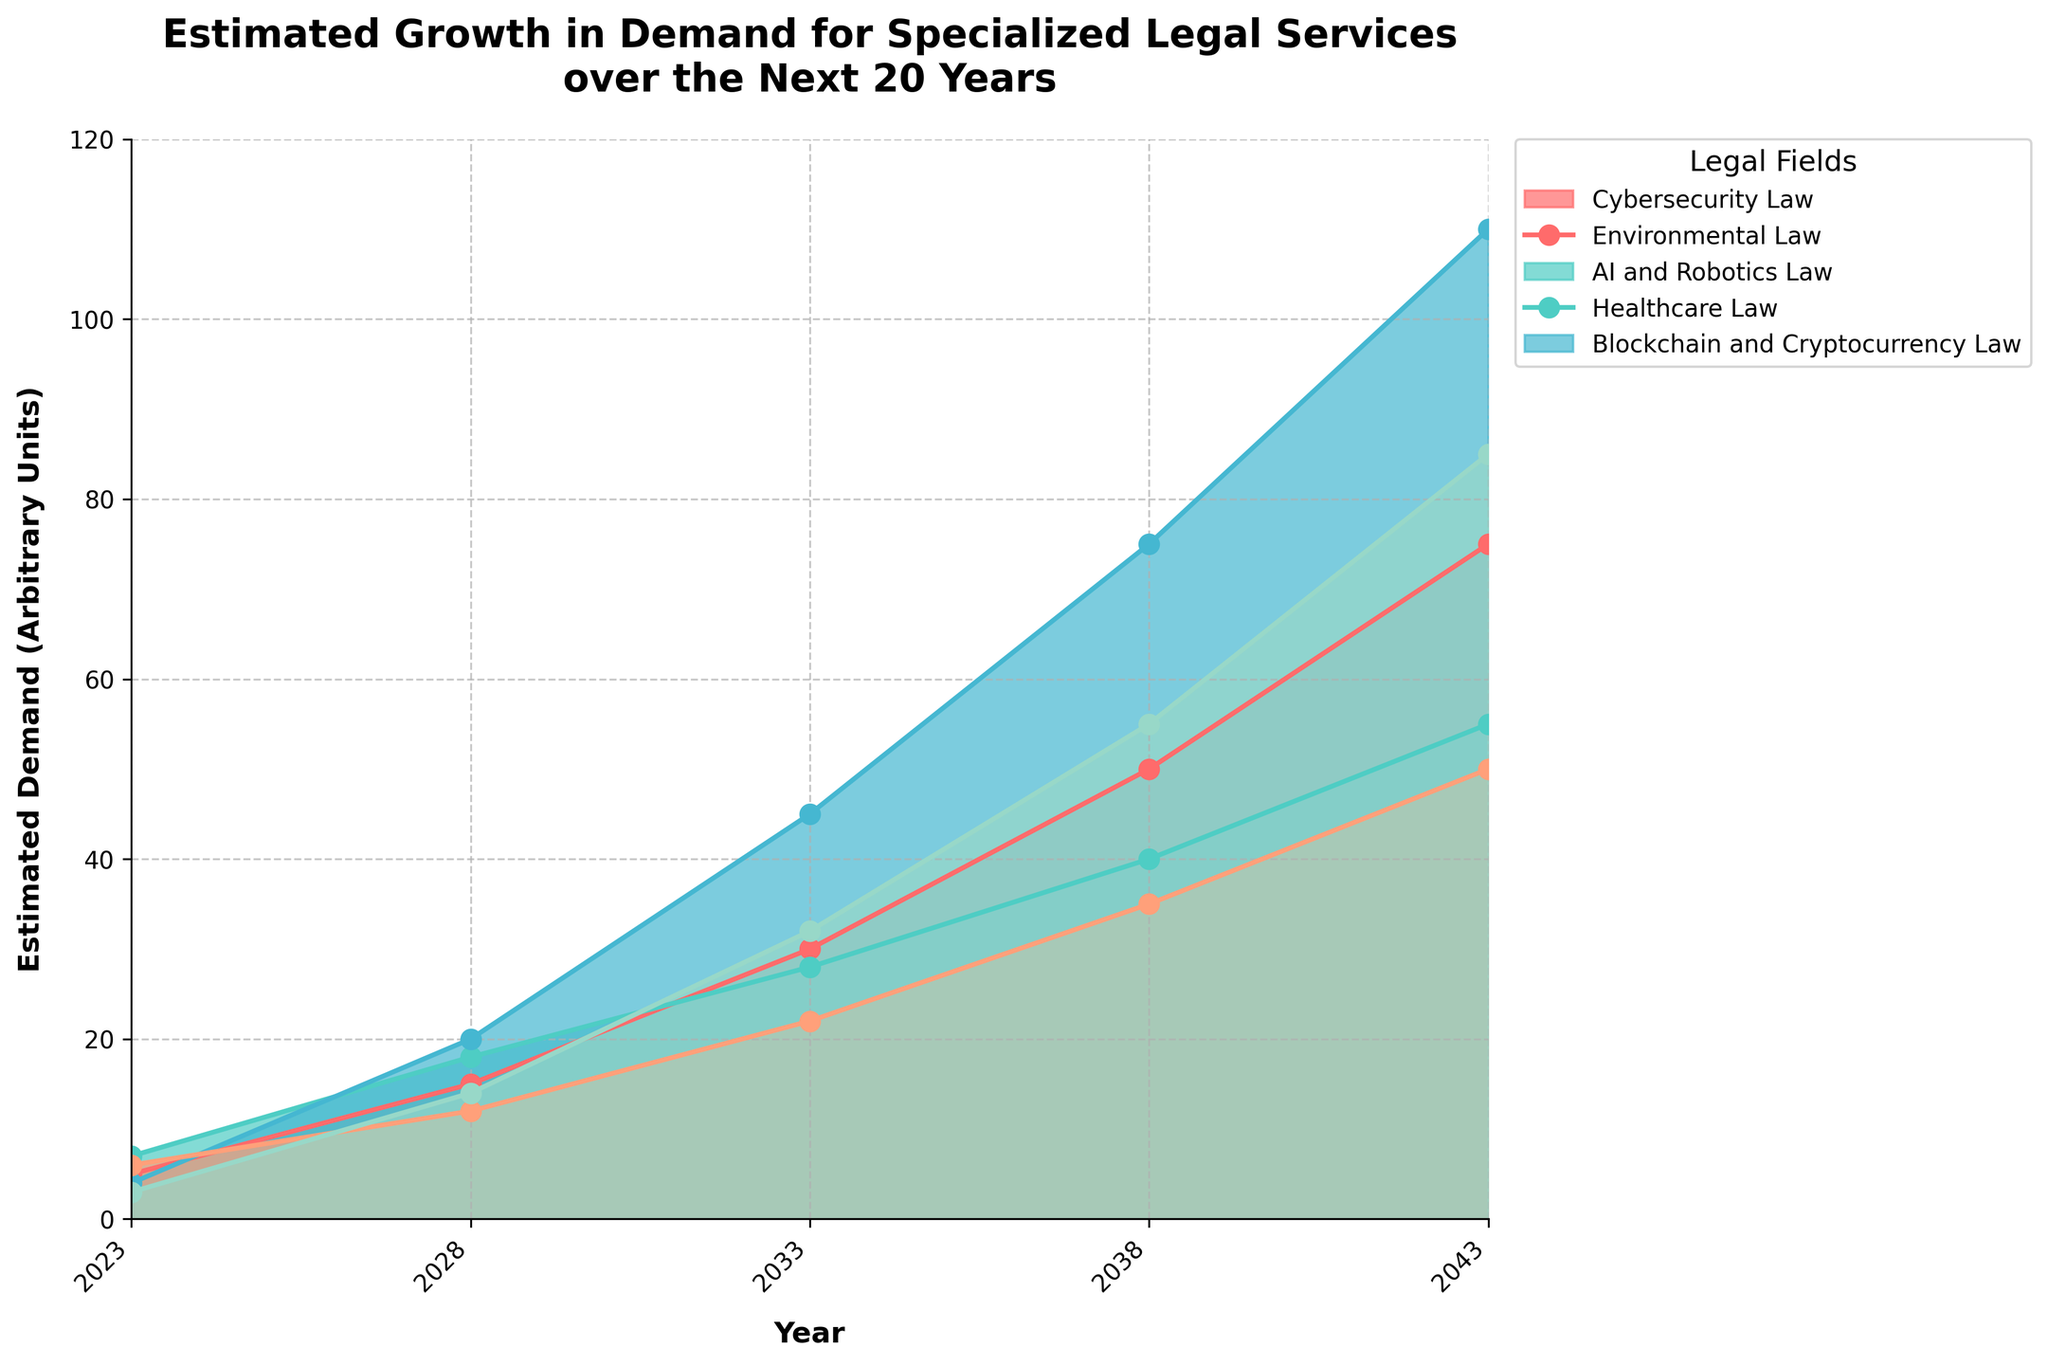what is the title of the chart? The title of the chart is found at the top of the figure, commonly in a bold, large font to make it prominent. From the description of the code, the title is: 'Estimated Growth in Demand for Specialized Legal Services over the Next 20 Years'
Answer: Estimated Growth in Demand for Specialized Legal Services over the Next 20 Years how many legal fields are displayed on the chart? The chart displays data for different specialized legal fields. Each field is represented as a separate color in the plot. From the data provided, there are five fields: 'Cybersecurity Law,' 'Environmental Law,' 'AI and Robotics Law,' 'Healthcare Law,' and 'Blockchain and Cryptocurrency Law.'
Answer: 5 which legal field has the highest estimated demand in 2043? Look at the values for each legal field in the year 2043. The data for 2043 shows: Cybersecurity Law (75), Environmental Law (55), AI and Robotics Law (110), Healthcare Law (50), and Blockchain and Cryptocurrency Law (85). AI and Robotics Law has the highest value at 110.
Answer: AI and Robotics Law between which years is the increase in demand for Environmental Law the steepest? Examine the plotted line for Environmental Law to determine the segment with the steepest slope, indicating the fastest increase. The most significant rise occurs between 2023 (7) and 2028 (18), totaling an increase of 11 units in 5 years, which is the highest slope.
Answer: 2023-2028 what is the approximate combined demand for Healthcare Law and Blockchain and Cryptocurrency Law in 2038? Add the estimated demands for Healthcare Law and Blockchain and Cryptocurrency Law for the year 2038. From the data: Healthcare Law (35) + Blockchain and Cryptocurrency Law (55). Hence, the combined demand is 35 + 55 = 90.
Answer: 90 which legal field shows the least growth between 2023 and 2043? The growth is calculated by taking the difference between the values for 2043 and 2023 for each legal field. From the data: 
Cybersecurity Law: 75 - 5 = 70, 
Environmental Law: 55 - 7 = 48, 
AI and Robotics Law: 110 - 4 = 106, 
Healthcare Law: 50 - 6 = 44, 
Blockchain and Cryptocurrency Law: 85 - 3 = 82.
Healthcare Law shows the least growth (44).
Answer: Healthcare Law what is the average estimated demand for AI and Robotics Law across all years shown? Calculate the average by summing the demand values for AI and Robotics Law across all years and then dividing by the number of years. Data: 4, 20, 45, 75, 110. The sum is 4 + 20 + 45 + 75 + 110 = 254. There are 5 years. The average is 254 / 5 = 50.8.
Answer: 50.8 which legal field shows a steady linear-like growth rather than exponential growth over the period? Look for a field whose plotted line appears more as a straight, steady line rather than a curve that becomes increasingly steep (exponential growth). Environmental Law’s line grows steadily and seems more linear compared to others with sharper rises like AI and Robotics Law.
Answer: Environmental Law 